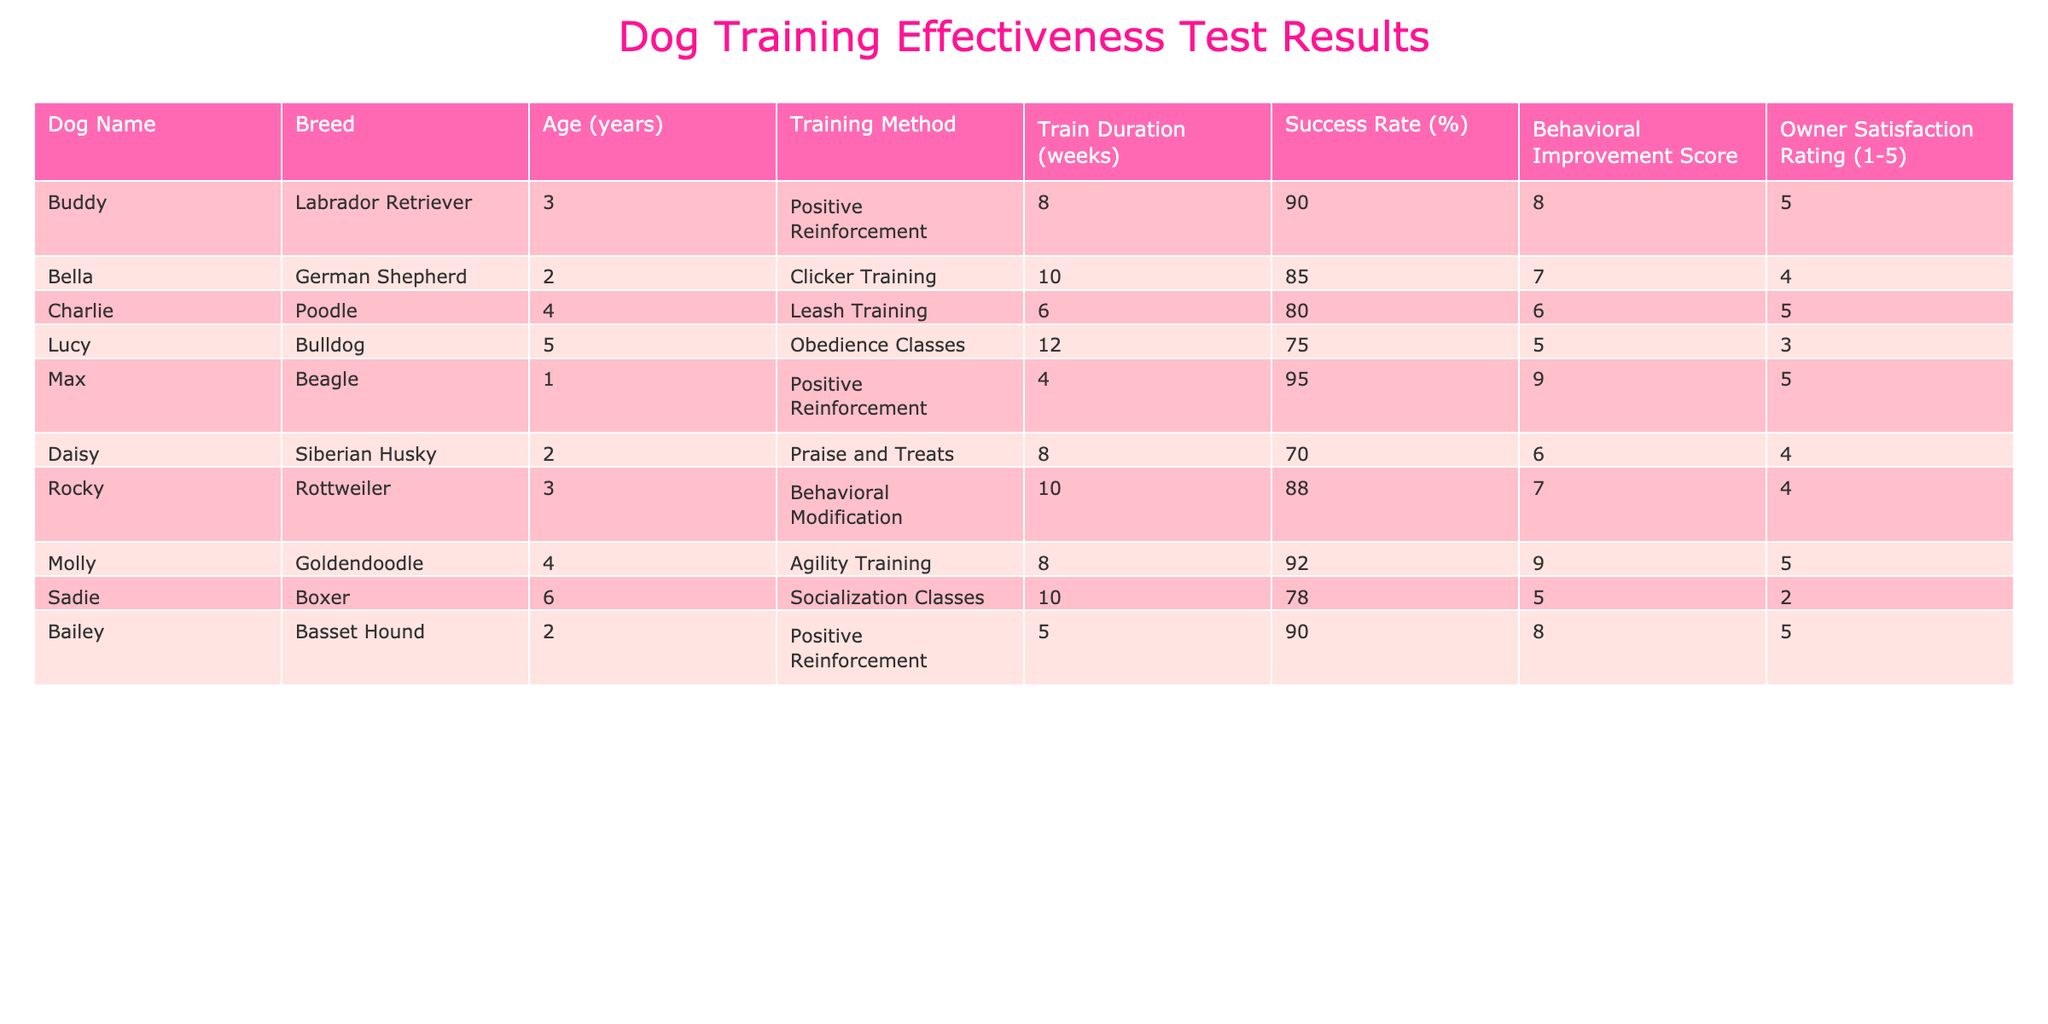What is the success rate of Buddy? Buddy has a success rate of 90%, which is directly listed in the training results table for his row.
Answer: 90% Which dog received the highest owner satisfaction rating? Looking through the table, both Buddy, Charlie, Max, Molly, and Bailey have an owner satisfaction rating of 5. Since multiple dogs have the same rating, the highest is 5, and they are all equally rated.
Answer: 5 What is the average training duration of all dogs? The training durations for all dogs are: 8, 10, 6, 12, 4, 8, 10, 8, 10, and 5 weeks. Adding these values gives 81 and dividing by the number of dogs (10) results in an average of 8.1 weeks.
Answer: 8.1 Is the success rate of Max higher than that of Daisy? Max's success rate is 95% while Daisy's is 70%. Since 95% is greater than 70%, the answer is yes.
Answer: Yes Which training method had the lowest average behavioral improvement score? The behavioral improvement scores are: 8, 7, 6, 5, 9, 6, 7, 9, 5, and 8. The lowest score is 5, associated with Lucy and Sadie. The average for other methods can be calculated, but the lowest is already identified.
Answer: 5 How many dogs achieved a success rate of 90% or above? The dogs with success rates of 90% or above are Buddy (90%), Max (95%), and Molly (92%), making a total of 3 dogs.
Answer: 3 What is the difference between the highest and lowest satisfaction ratings? The highest satisfaction rating is 5 (Buddy, Charlie, Max, Molly, and Bailey), and the lowest is 2 (Sadie). The difference is 5 - 2 = 3.
Answer: 3 Which breed had the highest success rate? Inspecting the success rates, Max (Beagle) has the highest success rate of 95%. Other contenders are Buddy and Molly, but Max holds the top position.
Answer: Beagle What proportion of dogs underwent Obedience Classes? Only one dog, Lucy, underwent Obedience Classes out of a total of 10 dogs. Hence the proportion is 1/10 or 10%.
Answer: 10% 